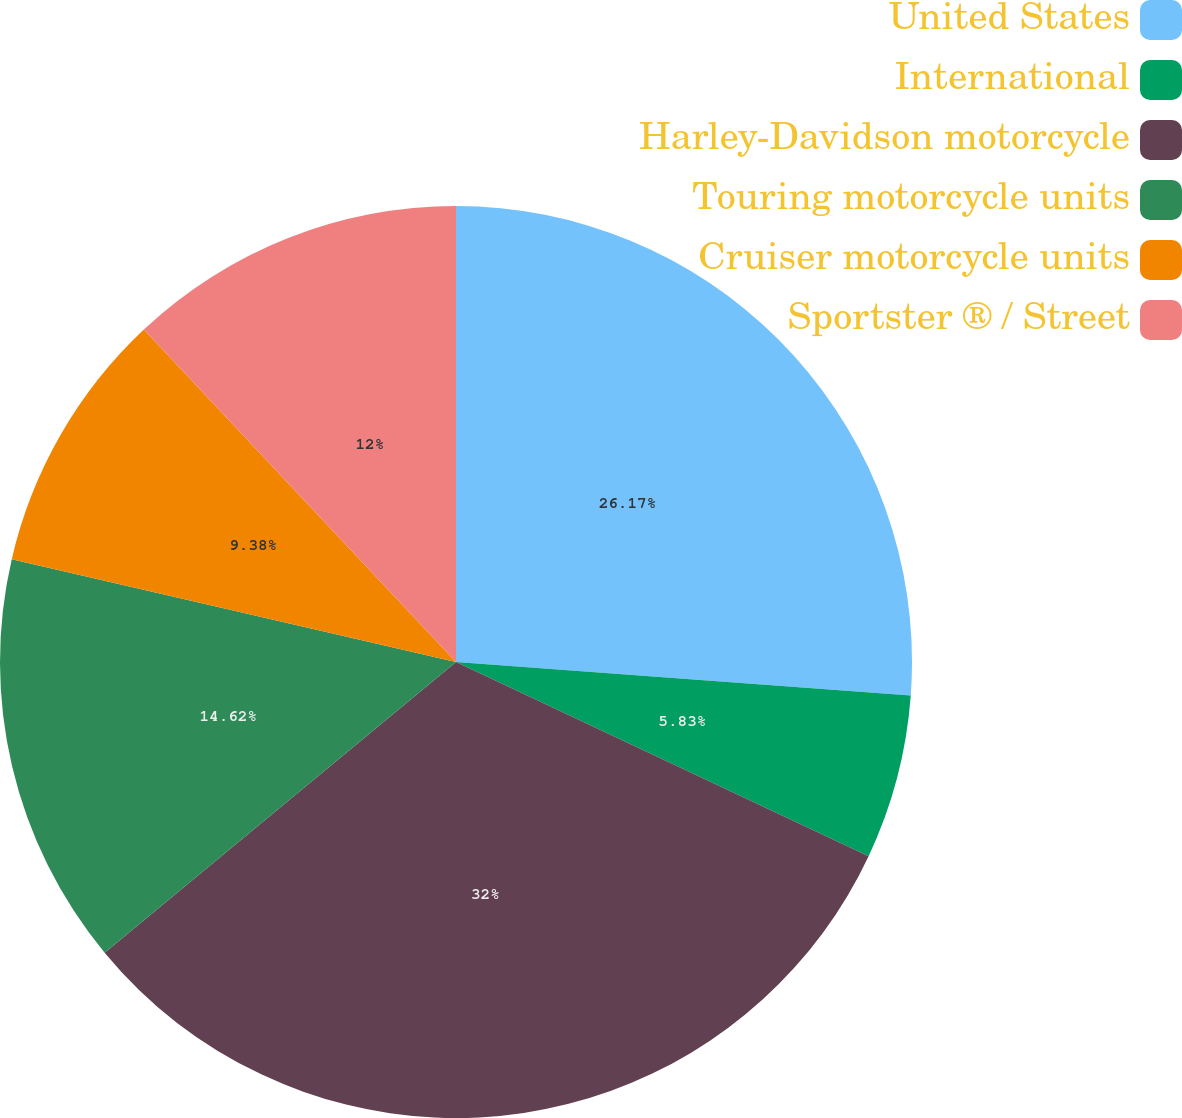<chart> <loc_0><loc_0><loc_500><loc_500><pie_chart><fcel>United States<fcel>International<fcel>Harley-Davidson motorcycle<fcel>Touring motorcycle units<fcel>Cruiser motorcycle units<fcel>Sportster ® / Street<nl><fcel>26.17%<fcel>5.83%<fcel>32.0%<fcel>14.62%<fcel>9.38%<fcel>12.0%<nl></chart> 